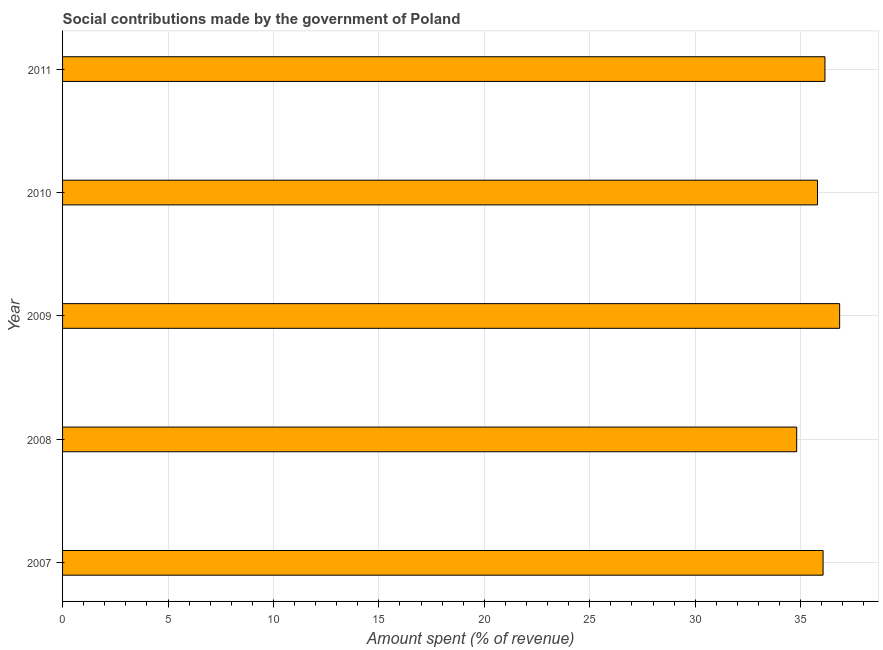Does the graph contain grids?
Offer a very short reply. Yes. What is the title of the graph?
Make the answer very short. Social contributions made by the government of Poland. What is the label or title of the X-axis?
Offer a very short reply. Amount spent (% of revenue). What is the label or title of the Y-axis?
Provide a succinct answer. Year. What is the amount spent in making social contributions in 2009?
Provide a succinct answer. 36.85. Across all years, what is the maximum amount spent in making social contributions?
Make the answer very short. 36.85. Across all years, what is the minimum amount spent in making social contributions?
Provide a short and direct response. 34.81. In which year was the amount spent in making social contributions maximum?
Keep it short and to the point. 2009. What is the sum of the amount spent in making social contributions?
Your response must be concise. 179.67. What is the difference between the amount spent in making social contributions in 2008 and 2011?
Offer a terse response. -1.34. What is the average amount spent in making social contributions per year?
Provide a short and direct response. 35.93. What is the median amount spent in making social contributions?
Give a very brief answer. 36.06. In how many years, is the amount spent in making social contributions greater than 12 %?
Offer a terse response. 5. What is the ratio of the amount spent in making social contributions in 2008 to that in 2010?
Your answer should be compact. 0.97. Is the difference between the amount spent in making social contributions in 2008 and 2011 greater than the difference between any two years?
Make the answer very short. No. What is the difference between the highest and the second highest amount spent in making social contributions?
Provide a short and direct response. 0.7. Is the sum of the amount spent in making social contributions in 2008 and 2009 greater than the maximum amount spent in making social contributions across all years?
Give a very brief answer. Yes. What is the difference between the highest and the lowest amount spent in making social contributions?
Offer a very short reply. 2.04. In how many years, is the amount spent in making social contributions greater than the average amount spent in making social contributions taken over all years?
Provide a short and direct response. 3. Are all the bars in the graph horizontal?
Keep it short and to the point. Yes. What is the difference between two consecutive major ticks on the X-axis?
Offer a terse response. 5. What is the Amount spent (% of revenue) in 2007?
Provide a short and direct response. 36.06. What is the Amount spent (% of revenue) in 2008?
Offer a terse response. 34.81. What is the Amount spent (% of revenue) of 2009?
Offer a very short reply. 36.85. What is the Amount spent (% of revenue) in 2010?
Provide a short and direct response. 35.8. What is the Amount spent (% of revenue) of 2011?
Your answer should be compact. 36.15. What is the difference between the Amount spent (% of revenue) in 2007 and 2008?
Ensure brevity in your answer.  1.25. What is the difference between the Amount spent (% of revenue) in 2007 and 2009?
Your response must be concise. -0.79. What is the difference between the Amount spent (% of revenue) in 2007 and 2010?
Offer a terse response. 0.26. What is the difference between the Amount spent (% of revenue) in 2007 and 2011?
Provide a succinct answer. -0.09. What is the difference between the Amount spent (% of revenue) in 2008 and 2009?
Keep it short and to the point. -2.04. What is the difference between the Amount spent (% of revenue) in 2008 and 2010?
Provide a short and direct response. -0.99. What is the difference between the Amount spent (% of revenue) in 2008 and 2011?
Provide a short and direct response. -1.34. What is the difference between the Amount spent (% of revenue) in 2009 and 2010?
Your response must be concise. 1.05. What is the difference between the Amount spent (% of revenue) in 2009 and 2011?
Give a very brief answer. 0.7. What is the difference between the Amount spent (% of revenue) in 2010 and 2011?
Provide a short and direct response. -0.35. What is the ratio of the Amount spent (% of revenue) in 2007 to that in 2008?
Offer a terse response. 1.04. What is the ratio of the Amount spent (% of revenue) in 2007 to that in 2009?
Offer a terse response. 0.98. What is the ratio of the Amount spent (% of revenue) in 2007 to that in 2010?
Provide a short and direct response. 1.01. What is the ratio of the Amount spent (% of revenue) in 2008 to that in 2009?
Your response must be concise. 0.94. What is the ratio of the Amount spent (% of revenue) in 2008 to that in 2010?
Offer a terse response. 0.97. What is the ratio of the Amount spent (% of revenue) in 2010 to that in 2011?
Offer a very short reply. 0.99. 